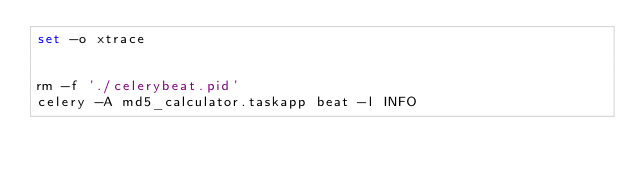<code> <loc_0><loc_0><loc_500><loc_500><_Bash_>set -o xtrace


rm -f './celerybeat.pid'
celery -A md5_calculator.taskapp beat -l INFO
</code> 